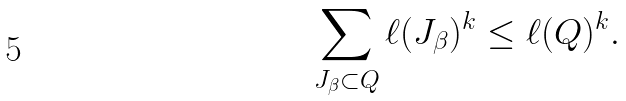<formula> <loc_0><loc_0><loc_500><loc_500>\sum _ { J _ { \beta } \subset Q } \ell ( J _ { \beta } ) ^ { k } \leq \ell ( Q ) ^ { k } .</formula> 